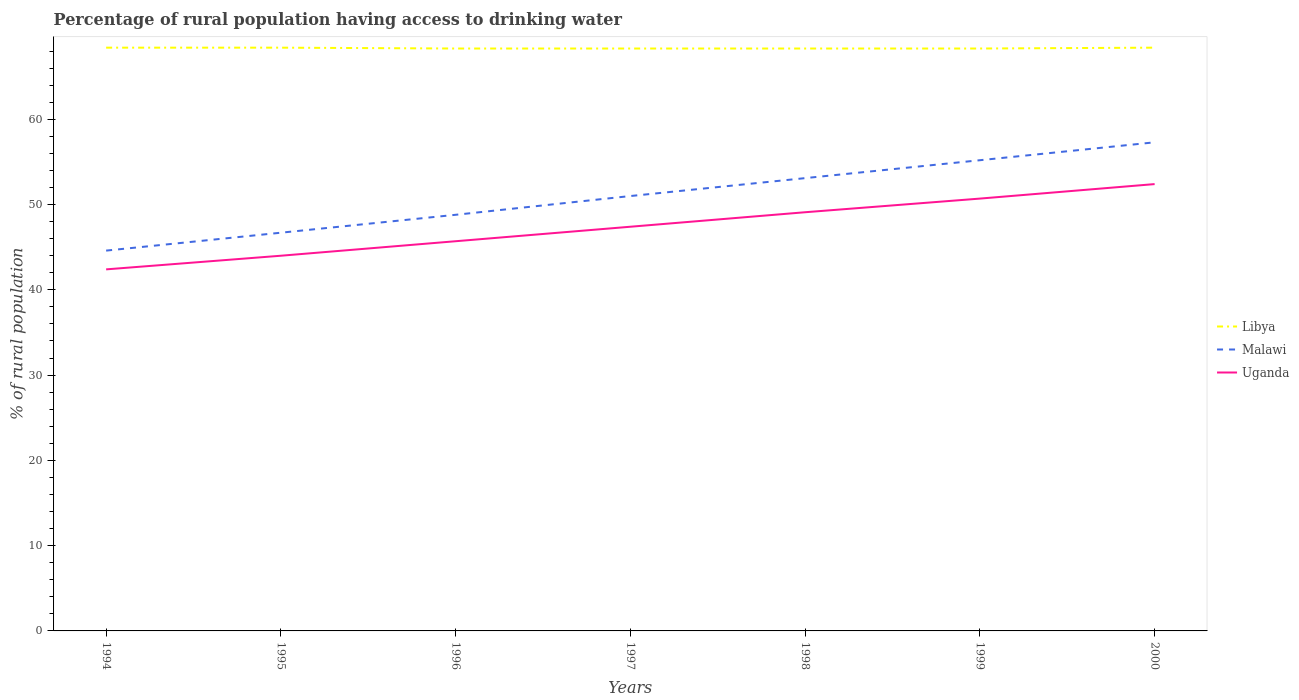Across all years, what is the maximum percentage of rural population having access to drinking water in Uganda?
Your answer should be very brief. 42.4. In which year was the percentage of rural population having access to drinking water in Malawi maximum?
Offer a terse response. 1994. What is the total percentage of rural population having access to drinking water in Malawi in the graph?
Provide a short and direct response. -10.6. What is the difference between the highest and the second highest percentage of rural population having access to drinking water in Libya?
Make the answer very short. 0.1. What is the difference between the highest and the lowest percentage of rural population having access to drinking water in Libya?
Offer a very short reply. 3. Is the percentage of rural population having access to drinking water in Uganda strictly greater than the percentage of rural population having access to drinking water in Libya over the years?
Your answer should be compact. Yes. How many years are there in the graph?
Offer a terse response. 7. Are the values on the major ticks of Y-axis written in scientific E-notation?
Your answer should be very brief. No. Does the graph contain any zero values?
Provide a succinct answer. No. Does the graph contain grids?
Provide a short and direct response. No. How many legend labels are there?
Provide a short and direct response. 3. What is the title of the graph?
Offer a very short reply. Percentage of rural population having access to drinking water. What is the label or title of the X-axis?
Your response must be concise. Years. What is the label or title of the Y-axis?
Your answer should be compact. % of rural population. What is the % of rural population in Libya in 1994?
Make the answer very short. 68.4. What is the % of rural population of Malawi in 1994?
Your answer should be very brief. 44.6. What is the % of rural population of Uganda in 1994?
Your response must be concise. 42.4. What is the % of rural population in Libya in 1995?
Keep it short and to the point. 68.4. What is the % of rural population in Malawi in 1995?
Make the answer very short. 46.7. What is the % of rural population of Uganda in 1995?
Your answer should be compact. 44. What is the % of rural population of Libya in 1996?
Provide a short and direct response. 68.3. What is the % of rural population of Malawi in 1996?
Your answer should be very brief. 48.8. What is the % of rural population in Uganda in 1996?
Offer a terse response. 45.7. What is the % of rural population of Libya in 1997?
Provide a short and direct response. 68.3. What is the % of rural population in Malawi in 1997?
Keep it short and to the point. 51. What is the % of rural population of Uganda in 1997?
Ensure brevity in your answer.  47.4. What is the % of rural population of Libya in 1998?
Provide a succinct answer. 68.3. What is the % of rural population of Malawi in 1998?
Your response must be concise. 53.1. What is the % of rural population of Uganda in 1998?
Give a very brief answer. 49.1. What is the % of rural population in Libya in 1999?
Offer a terse response. 68.3. What is the % of rural population of Malawi in 1999?
Your response must be concise. 55.2. What is the % of rural population in Uganda in 1999?
Keep it short and to the point. 50.7. What is the % of rural population of Libya in 2000?
Give a very brief answer. 68.4. What is the % of rural population of Malawi in 2000?
Your response must be concise. 57.3. What is the % of rural population in Uganda in 2000?
Make the answer very short. 52.4. Across all years, what is the maximum % of rural population of Libya?
Provide a short and direct response. 68.4. Across all years, what is the maximum % of rural population in Malawi?
Give a very brief answer. 57.3. Across all years, what is the maximum % of rural population of Uganda?
Ensure brevity in your answer.  52.4. Across all years, what is the minimum % of rural population in Libya?
Ensure brevity in your answer.  68.3. Across all years, what is the minimum % of rural population in Malawi?
Your answer should be very brief. 44.6. Across all years, what is the minimum % of rural population of Uganda?
Keep it short and to the point. 42.4. What is the total % of rural population of Libya in the graph?
Your response must be concise. 478.4. What is the total % of rural population of Malawi in the graph?
Your answer should be very brief. 356.7. What is the total % of rural population of Uganda in the graph?
Your answer should be very brief. 331.7. What is the difference between the % of rural population of Libya in 1994 and that in 1995?
Ensure brevity in your answer.  0. What is the difference between the % of rural population of Malawi in 1994 and that in 1995?
Ensure brevity in your answer.  -2.1. What is the difference between the % of rural population in Uganda in 1994 and that in 1995?
Ensure brevity in your answer.  -1.6. What is the difference between the % of rural population in Libya in 1994 and that in 1996?
Your response must be concise. 0.1. What is the difference between the % of rural population of Malawi in 1994 and that in 1996?
Your answer should be compact. -4.2. What is the difference between the % of rural population of Uganda in 1994 and that in 1997?
Provide a succinct answer. -5. What is the difference between the % of rural population in Libya in 1994 and that in 2000?
Ensure brevity in your answer.  0. What is the difference between the % of rural population of Malawi in 1994 and that in 2000?
Make the answer very short. -12.7. What is the difference between the % of rural population of Uganda in 1994 and that in 2000?
Ensure brevity in your answer.  -10. What is the difference between the % of rural population in Uganda in 1995 and that in 1996?
Provide a short and direct response. -1.7. What is the difference between the % of rural population in Libya in 1995 and that in 1997?
Offer a very short reply. 0.1. What is the difference between the % of rural population in Malawi in 1995 and that in 1997?
Your answer should be compact. -4.3. What is the difference between the % of rural population of Libya in 1995 and that in 1998?
Your answer should be compact. 0.1. What is the difference between the % of rural population in Uganda in 1995 and that in 1998?
Provide a short and direct response. -5.1. What is the difference between the % of rural population in Malawi in 1995 and that in 1999?
Your response must be concise. -8.5. What is the difference between the % of rural population of Uganda in 1995 and that in 1999?
Your answer should be very brief. -6.7. What is the difference between the % of rural population of Libya in 1995 and that in 2000?
Your response must be concise. 0. What is the difference between the % of rural population in Malawi in 1995 and that in 2000?
Ensure brevity in your answer.  -10.6. What is the difference between the % of rural population of Libya in 1996 and that in 1997?
Keep it short and to the point. 0. What is the difference between the % of rural population in Malawi in 1996 and that in 1997?
Your answer should be very brief. -2.2. What is the difference between the % of rural population in Uganda in 1996 and that in 1997?
Offer a terse response. -1.7. What is the difference between the % of rural population in Libya in 1996 and that in 1998?
Your response must be concise. 0. What is the difference between the % of rural population in Malawi in 1996 and that in 1998?
Provide a succinct answer. -4.3. What is the difference between the % of rural population of Libya in 1997 and that in 1999?
Provide a succinct answer. 0. What is the difference between the % of rural population in Malawi in 1997 and that in 1999?
Give a very brief answer. -4.2. What is the difference between the % of rural population of Uganda in 1997 and that in 1999?
Your answer should be very brief. -3.3. What is the difference between the % of rural population in Libya in 1997 and that in 2000?
Your response must be concise. -0.1. What is the difference between the % of rural population of Malawi in 1997 and that in 2000?
Give a very brief answer. -6.3. What is the difference between the % of rural population of Malawi in 1998 and that in 2000?
Give a very brief answer. -4.2. What is the difference between the % of rural population in Uganda in 1998 and that in 2000?
Your response must be concise. -3.3. What is the difference between the % of rural population in Libya in 1999 and that in 2000?
Your response must be concise. -0.1. What is the difference between the % of rural population in Uganda in 1999 and that in 2000?
Provide a short and direct response. -1.7. What is the difference between the % of rural population in Libya in 1994 and the % of rural population in Malawi in 1995?
Provide a succinct answer. 21.7. What is the difference between the % of rural population in Libya in 1994 and the % of rural population in Uganda in 1995?
Ensure brevity in your answer.  24.4. What is the difference between the % of rural population of Libya in 1994 and the % of rural population of Malawi in 1996?
Offer a very short reply. 19.6. What is the difference between the % of rural population in Libya in 1994 and the % of rural population in Uganda in 1996?
Your answer should be very brief. 22.7. What is the difference between the % of rural population in Libya in 1994 and the % of rural population in Malawi in 1997?
Keep it short and to the point. 17.4. What is the difference between the % of rural population in Libya in 1994 and the % of rural population in Uganda in 1997?
Keep it short and to the point. 21. What is the difference between the % of rural population in Libya in 1994 and the % of rural population in Uganda in 1998?
Your answer should be compact. 19.3. What is the difference between the % of rural population in Malawi in 1994 and the % of rural population in Uganda in 1998?
Offer a very short reply. -4.5. What is the difference between the % of rural population in Libya in 1994 and the % of rural population in Malawi in 2000?
Your response must be concise. 11.1. What is the difference between the % of rural population of Libya in 1994 and the % of rural population of Uganda in 2000?
Offer a terse response. 16. What is the difference between the % of rural population of Libya in 1995 and the % of rural population of Malawi in 1996?
Provide a succinct answer. 19.6. What is the difference between the % of rural population in Libya in 1995 and the % of rural population in Uganda in 1996?
Provide a succinct answer. 22.7. What is the difference between the % of rural population in Malawi in 1995 and the % of rural population in Uganda in 1996?
Make the answer very short. 1. What is the difference between the % of rural population of Libya in 1995 and the % of rural population of Malawi in 1998?
Keep it short and to the point. 15.3. What is the difference between the % of rural population in Libya in 1995 and the % of rural population in Uganda in 1998?
Your answer should be very brief. 19.3. What is the difference between the % of rural population in Malawi in 1995 and the % of rural population in Uganda in 1998?
Your answer should be compact. -2.4. What is the difference between the % of rural population in Malawi in 1995 and the % of rural population in Uganda in 2000?
Offer a terse response. -5.7. What is the difference between the % of rural population in Libya in 1996 and the % of rural population in Malawi in 1997?
Provide a short and direct response. 17.3. What is the difference between the % of rural population of Libya in 1996 and the % of rural population of Uganda in 1997?
Your answer should be very brief. 20.9. What is the difference between the % of rural population of Malawi in 1996 and the % of rural population of Uganda in 1997?
Provide a short and direct response. 1.4. What is the difference between the % of rural population in Libya in 1996 and the % of rural population in Uganda in 1998?
Your answer should be compact. 19.2. What is the difference between the % of rural population of Malawi in 1996 and the % of rural population of Uganda in 1998?
Your response must be concise. -0.3. What is the difference between the % of rural population of Libya in 1996 and the % of rural population of Malawi in 1999?
Make the answer very short. 13.1. What is the difference between the % of rural population of Malawi in 1996 and the % of rural population of Uganda in 1999?
Offer a terse response. -1.9. What is the difference between the % of rural population in Libya in 1996 and the % of rural population in Malawi in 2000?
Make the answer very short. 11. What is the difference between the % of rural population in Libya in 1996 and the % of rural population in Uganda in 2000?
Ensure brevity in your answer.  15.9. What is the difference between the % of rural population of Libya in 1997 and the % of rural population of Malawi in 1998?
Offer a terse response. 15.2. What is the difference between the % of rural population in Libya in 1997 and the % of rural population in Uganda in 1998?
Ensure brevity in your answer.  19.2. What is the difference between the % of rural population of Malawi in 1997 and the % of rural population of Uganda in 1999?
Your response must be concise. 0.3. What is the difference between the % of rural population of Libya in 1997 and the % of rural population of Malawi in 2000?
Your answer should be compact. 11. What is the difference between the % of rural population of Libya in 1997 and the % of rural population of Uganda in 2000?
Provide a succinct answer. 15.9. What is the difference between the % of rural population in Malawi in 1997 and the % of rural population in Uganda in 2000?
Your response must be concise. -1.4. What is the difference between the % of rural population of Malawi in 1998 and the % of rural population of Uganda in 1999?
Give a very brief answer. 2.4. What is the difference between the % of rural population in Libya in 1998 and the % of rural population in Malawi in 2000?
Your response must be concise. 11. What is the average % of rural population of Libya per year?
Provide a succinct answer. 68.34. What is the average % of rural population of Malawi per year?
Provide a short and direct response. 50.96. What is the average % of rural population in Uganda per year?
Your answer should be very brief. 47.39. In the year 1994, what is the difference between the % of rural population of Libya and % of rural population of Malawi?
Provide a succinct answer. 23.8. In the year 1995, what is the difference between the % of rural population in Libya and % of rural population in Malawi?
Provide a short and direct response. 21.7. In the year 1995, what is the difference between the % of rural population of Libya and % of rural population of Uganda?
Your response must be concise. 24.4. In the year 1996, what is the difference between the % of rural population of Libya and % of rural population of Uganda?
Provide a short and direct response. 22.6. In the year 1996, what is the difference between the % of rural population in Malawi and % of rural population in Uganda?
Offer a terse response. 3.1. In the year 1997, what is the difference between the % of rural population in Libya and % of rural population in Uganda?
Provide a short and direct response. 20.9. In the year 1997, what is the difference between the % of rural population in Malawi and % of rural population in Uganda?
Ensure brevity in your answer.  3.6. In the year 1998, what is the difference between the % of rural population of Libya and % of rural population of Malawi?
Offer a terse response. 15.2. In the year 1998, what is the difference between the % of rural population of Libya and % of rural population of Uganda?
Provide a short and direct response. 19.2. In the year 1999, what is the difference between the % of rural population of Libya and % of rural population of Malawi?
Ensure brevity in your answer.  13.1. In the year 1999, what is the difference between the % of rural population of Libya and % of rural population of Uganda?
Your response must be concise. 17.6. In the year 1999, what is the difference between the % of rural population in Malawi and % of rural population in Uganda?
Your response must be concise. 4.5. In the year 2000, what is the difference between the % of rural population in Malawi and % of rural population in Uganda?
Your response must be concise. 4.9. What is the ratio of the % of rural population of Libya in 1994 to that in 1995?
Provide a succinct answer. 1. What is the ratio of the % of rural population in Malawi in 1994 to that in 1995?
Provide a short and direct response. 0.95. What is the ratio of the % of rural population of Uganda in 1994 to that in 1995?
Make the answer very short. 0.96. What is the ratio of the % of rural population of Libya in 1994 to that in 1996?
Make the answer very short. 1. What is the ratio of the % of rural population of Malawi in 1994 to that in 1996?
Keep it short and to the point. 0.91. What is the ratio of the % of rural population of Uganda in 1994 to that in 1996?
Your answer should be very brief. 0.93. What is the ratio of the % of rural population of Malawi in 1994 to that in 1997?
Make the answer very short. 0.87. What is the ratio of the % of rural population in Uganda in 1994 to that in 1997?
Offer a very short reply. 0.89. What is the ratio of the % of rural population of Libya in 1994 to that in 1998?
Ensure brevity in your answer.  1. What is the ratio of the % of rural population in Malawi in 1994 to that in 1998?
Provide a short and direct response. 0.84. What is the ratio of the % of rural population in Uganda in 1994 to that in 1998?
Provide a short and direct response. 0.86. What is the ratio of the % of rural population of Malawi in 1994 to that in 1999?
Ensure brevity in your answer.  0.81. What is the ratio of the % of rural population of Uganda in 1994 to that in 1999?
Make the answer very short. 0.84. What is the ratio of the % of rural population of Malawi in 1994 to that in 2000?
Your answer should be very brief. 0.78. What is the ratio of the % of rural population of Uganda in 1994 to that in 2000?
Offer a terse response. 0.81. What is the ratio of the % of rural population of Libya in 1995 to that in 1996?
Make the answer very short. 1. What is the ratio of the % of rural population of Malawi in 1995 to that in 1996?
Your answer should be compact. 0.96. What is the ratio of the % of rural population in Uganda in 1995 to that in 1996?
Keep it short and to the point. 0.96. What is the ratio of the % of rural population of Malawi in 1995 to that in 1997?
Ensure brevity in your answer.  0.92. What is the ratio of the % of rural population of Uganda in 1995 to that in 1997?
Offer a very short reply. 0.93. What is the ratio of the % of rural population in Malawi in 1995 to that in 1998?
Offer a very short reply. 0.88. What is the ratio of the % of rural population in Uganda in 1995 to that in 1998?
Offer a very short reply. 0.9. What is the ratio of the % of rural population of Libya in 1995 to that in 1999?
Provide a short and direct response. 1. What is the ratio of the % of rural population in Malawi in 1995 to that in 1999?
Keep it short and to the point. 0.85. What is the ratio of the % of rural population of Uganda in 1995 to that in 1999?
Your answer should be compact. 0.87. What is the ratio of the % of rural population of Libya in 1995 to that in 2000?
Give a very brief answer. 1. What is the ratio of the % of rural population in Malawi in 1995 to that in 2000?
Offer a terse response. 0.81. What is the ratio of the % of rural population of Uganda in 1995 to that in 2000?
Keep it short and to the point. 0.84. What is the ratio of the % of rural population in Libya in 1996 to that in 1997?
Keep it short and to the point. 1. What is the ratio of the % of rural population in Malawi in 1996 to that in 1997?
Your response must be concise. 0.96. What is the ratio of the % of rural population in Uganda in 1996 to that in 1997?
Offer a terse response. 0.96. What is the ratio of the % of rural population of Malawi in 1996 to that in 1998?
Provide a short and direct response. 0.92. What is the ratio of the % of rural population of Uganda in 1996 to that in 1998?
Offer a very short reply. 0.93. What is the ratio of the % of rural population of Libya in 1996 to that in 1999?
Your answer should be compact. 1. What is the ratio of the % of rural population in Malawi in 1996 to that in 1999?
Provide a succinct answer. 0.88. What is the ratio of the % of rural population of Uganda in 1996 to that in 1999?
Your answer should be very brief. 0.9. What is the ratio of the % of rural population of Libya in 1996 to that in 2000?
Provide a short and direct response. 1. What is the ratio of the % of rural population of Malawi in 1996 to that in 2000?
Ensure brevity in your answer.  0.85. What is the ratio of the % of rural population of Uganda in 1996 to that in 2000?
Your response must be concise. 0.87. What is the ratio of the % of rural population in Libya in 1997 to that in 1998?
Give a very brief answer. 1. What is the ratio of the % of rural population of Malawi in 1997 to that in 1998?
Give a very brief answer. 0.96. What is the ratio of the % of rural population in Uganda in 1997 to that in 1998?
Your response must be concise. 0.97. What is the ratio of the % of rural population of Libya in 1997 to that in 1999?
Offer a very short reply. 1. What is the ratio of the % of rural population in Malawi in 1997 to that in 1999?
Offer a terse response. 0.92. What is the ratio of the % of rural population of Uganda in 1997 to that in 1999?
Offer a terse response. 0.93. What is the ratio of the % of rural population in Malawi in 1997 to that in 2000?
Your answer should be compact. 0.89. What is the ratio of the % of rural population of Uganda in 1997 to that in 2000?
Offer a very short reply. 0.9. What is the ratio of the % of rural population of Malawi in 1998 to that in 1999?
Give a very brief answer. 0.96. What is the ratio of the % of rural population of Uganda in 1998 to that in 1999?
Your answer should be very brief. 0.97. What is the ratio of the % of rural population of Libya in 1998 to that in 2000?
Ensure brevity in your answer.  1. What is the ratio of the % of rural population in Malawi in 1998 to that in 2000?
Keep it short and to the point. 0.93. What is the ratio of the % of rural population in Uganda in 1998 to that in 2000?
Offer a terse response. 0.94. What is the ratio of the % of rural population of Libya in 1999 to that in 2000?
Your response must be concise. 1. What is the ratio of the % of rural population in Malawi in 1999 to that in 2000?
Your response must be concise. 0.96. What is the ratio of the % of rural population of Uganda in 1999 to that in 2000?
Offer a very short reply. 0.97. What is the difference between the highest and the second highest % of rural population in Malawi?
Your answer should be compact. 2.1. 